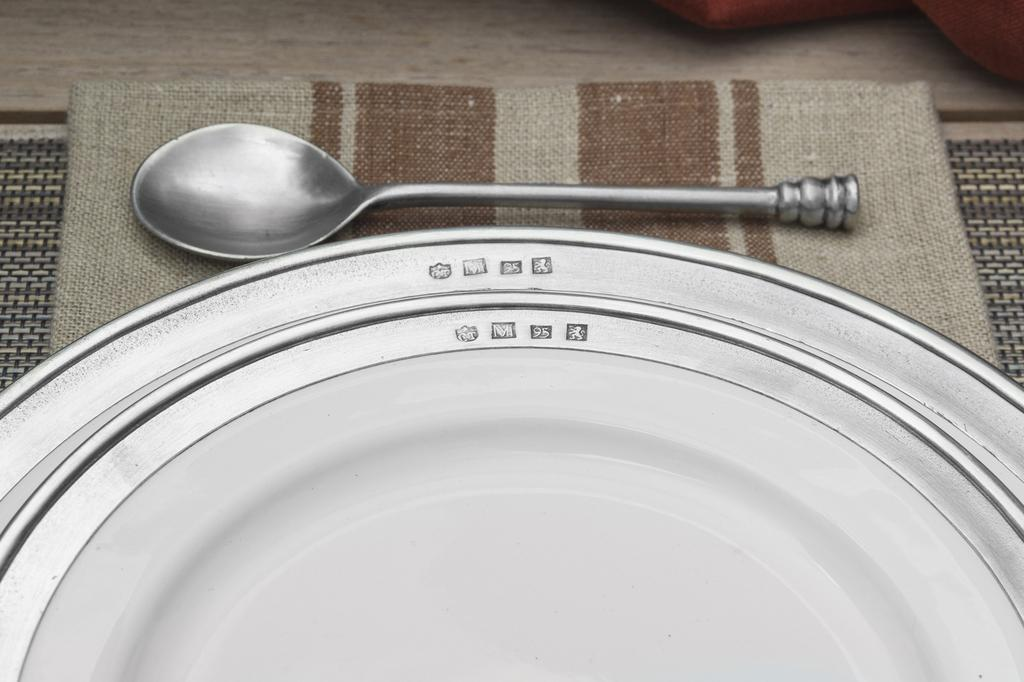What is the color of the plate in the image? The plate in the image is white. What type of utensil is present in the image? There is a steel spoon in the image. What is used to cover the plate and spoon in the image? One cloth is present under the plate and spoon, and another cloth is present on top of the plate and spoon. How many swings are visible in the image? There are no swings present in the image. What is the fifth item in the image? The image only contains four items: a white plate, a steel spoon, and two cloths. There is no fifth item. 